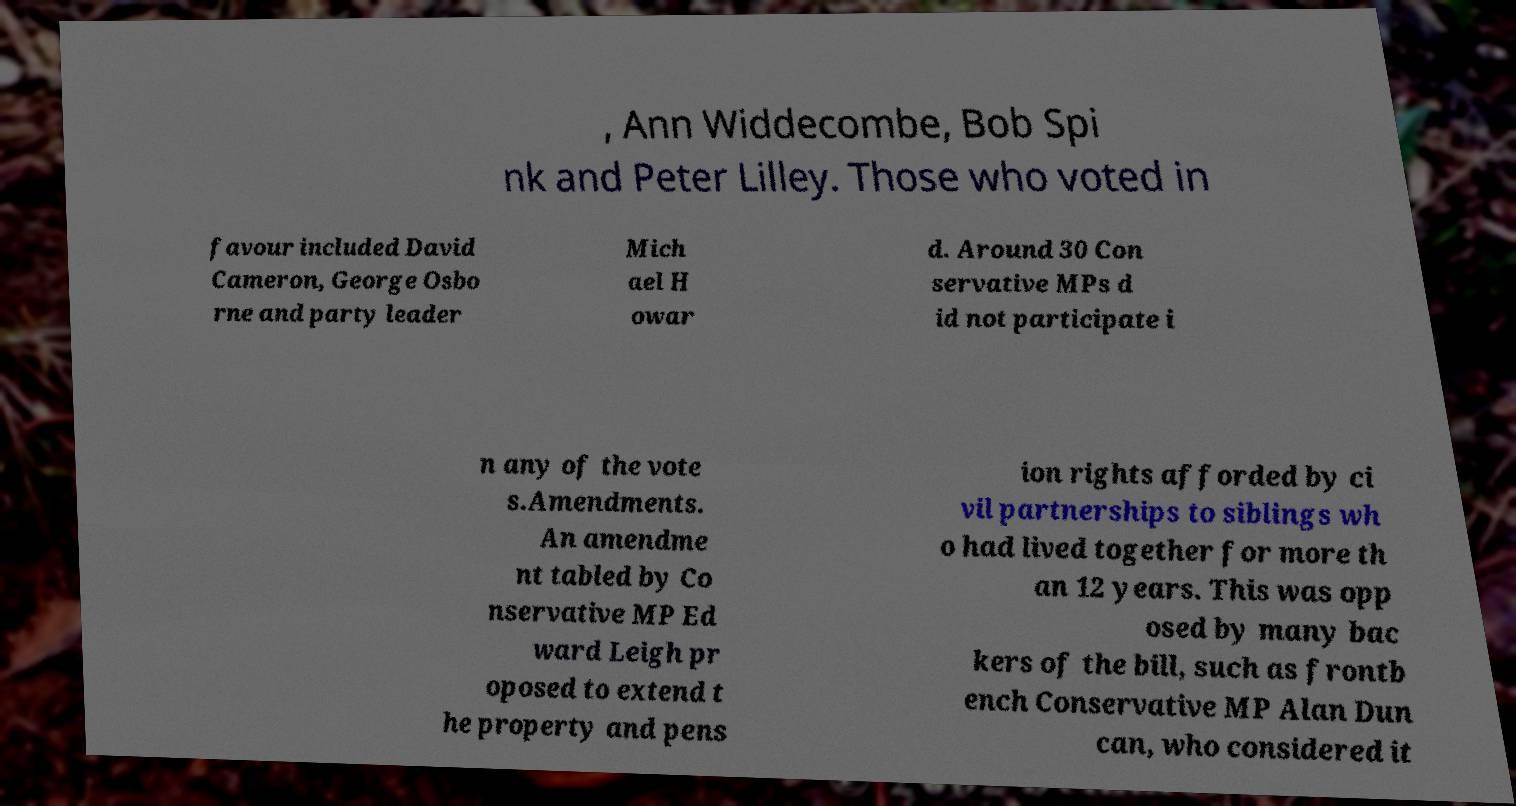Can you accurately transcribe the text from the provided image for me? , Ann Widdecombe, Bob Spi nk and Peter Lilley. Those who voted in favour included David Cameron, George Osbo rne and party leader Mich ael H owar d. Around 30 Con servative MPs d id not participate i n any of the vote s.Amendments. An amendme nt tabled by Co nservative MP Ed ward Leigh pr oposed to extend t he property and pens ion rights afforded by ci vil partnerships to siblings wh o had lived together for more th an 12 years. This was opp osed by many bac kers of the bill, such as frontb ench Conservative MP Alan Dun can, who considered it 